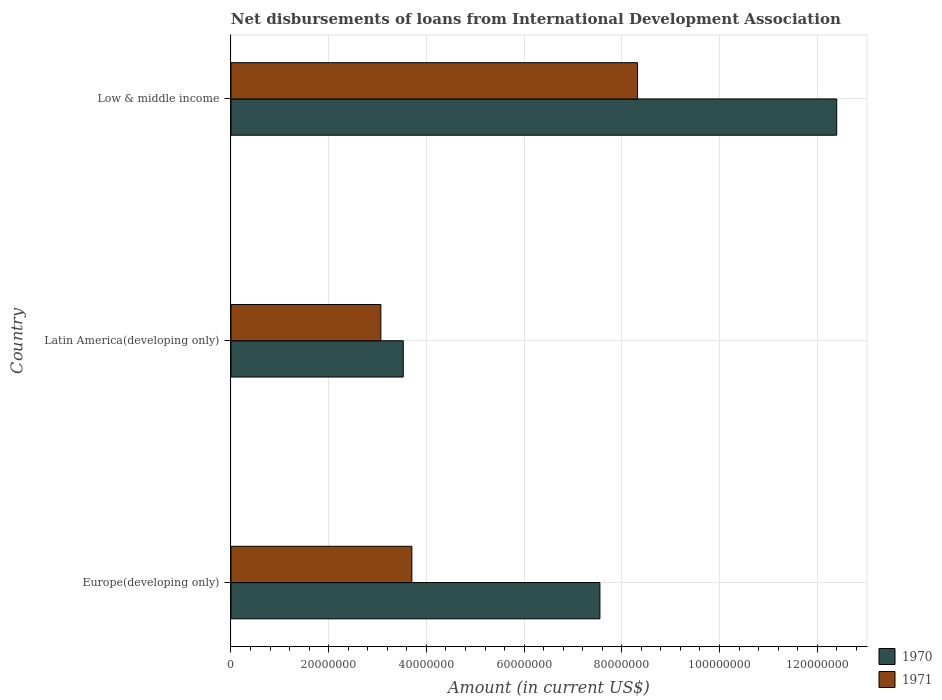How many different coloured bars are there?
Keep it short and to the point. 2. How many groups of bars are there?
Provide a succinct answer. 3. What is the amount of loans disbursed in 1971 in Low & middle income?
Make the answer very short. 8.32e+07. Across all countries, what is the maximum amount of loans disbursed in 1971?
Give a very brief answer. 8.32e+07. Across all countries, what is the minimum amount of loans disbursed in 1971?
Provide a succinct answer. 3.07e+07. In which country was the amount of loans disbursed in 1970 minimum?
Your answer should be very brief. Latin America(developing only). What is the total amount of loans disbursed in 1970 in the graph?
Your answer should be very brief. 2.35e+08. What is the difference between the amount of loans disbursed in 1971 in Europe(developing only) and that in Latin America(developing only)?
Provide a succinct answer. 6.35e+06. What is the difference between the amount of loans disbursed in 1970 in Europe(developing only) and the amount of loans disbursed in 1971 in Low & middle income?
Ensure brevity in your answer.  -7.70e+06. What is the average amount of loans disbursed in 1971 per country?
Give a very brief answer. 5.03e+07. What is the difference between the amount of loans disbursed in 1970 and amount of loans disbursed in 1971 in Low & middle income?
Make the answer very short. 4.08e+07. In how many countries, is the amount of loans disbursed in 1970 greater than 76000000 US$?
Ensure brevity in your answer.  1. What is the ratio of the amount of loans disbursed in 1971 in Europe(developing only) to that in Latin America(developing only)?
Ensure brevity in your answer.  1.21. Is the difference between the amount of loans disbursed in 1970 in Latin America(developing only) and Low & middle income greater than the difference between the amount of loans disbursed in 1971 in Latin America(developing only) and Low & middle income?
Provide a short and direct response. No. What is the difference between the highest and the second highest amount of loans disbursed in 1970?
Your response must be concise. 4.85e+07. What is the difference between the highest and the lowest amount of loans disbursed in 1970?
Keep it short and to the point. 8.87e+07. How many bars are there?
Your response must be concise. 6. Are all the bars in the graph horizontal?
Keep it short and to the point. Yes. How many countries are there in the graph?
Your answer should be compact. 3. Are the values on the major ticks of X-axis written in scientific E-notation?
Your response must be concise. No. Where does the legend appear in the graph?
Your answer should be compact. Bottom right. How many legend labels are there?
Your answer should be compact. 2. What is the title of the graph?
Keep it short and to the point. Net disbursements of loans from International Development Association. Does "1982" appear as one of the legend labels in the graph?
Make the answer very short. No. What is the label or title of the X-axis?
Make the answer very short. Amount (in current US$). What is the Amount (in current US$) in 1970 in Europe(developing only)?
Keep it short and to the point. 7.55e+07. What is the Amount (in current US$) of 1971 in Europe(developing only)?
Your answer should be very brief. 3.70e+07. What is the Amount (in current US$) in 1970 in Latin America(developing only)?
Give a very brief answer. 3.53e+07. What is the Amount (in current US$) of 1971 in Latin America(developing only)?
Make the answer very short. 3.07e+07. What is the Amount (in current US$) in 1970 in Low & middle income?
Your response must be concise. 1.24e+08. What is the Amount (in current US$) in 1971 in Low & middle income?
Provide a short and direct response. 8.32e+07. Across all countries, what is the maximum Amount (in current US$) in 1970?
Provide a succinct answer. 1.24e+08. Across all countries, what is the maximum Amount (in current US$) in 1971?
Provide a succinct answer. 8.32e+07. Across all countries, what is the minimum Amount (in current US$) of 1970?
Give a very brief answer. 3.53e+07. Across all countries, what is the minimum Amount (in current US$) in 1971?
Ensure brevity in your answer.  3.07e+07. What is the total Amount (in current US$) in 1970 in the graph?
Offer a very short reply. 2.35e+08. What is the total Amount (in current US$) of 1971 in the graph?
Your response must be concise. 1.51e+08. What is the difference between the Amount (in current US$) of 1970 in Europe(developing only) and that in Latin America(developing only)?
Keep it short and to the point. 4.03e+07. What is the difference between the Amount (in current US$) in 1971 in Europe(developing only) and that in Latin America(developing only)?
Give a very brief answer. 6.35e+06. What is the difference between the Amount (in current US$) of 1970 in Europe(developing only) and that in Low & middle income?
Provide a succinct answer. -4.85e+07. What is the difference between the Amount (in current US$) in 1971 in Europe(developing only) and that in Low & middle income?
Provide a succinct answer. -4.62e+07. What is the difference between the Amount (in current US$) of 1970 in Latin America(developing only) and that in Low & middle income?
Provide a short and direct response. -8.87e+07. What is the difference between the Amount (in current US$) in 1971 in Latin America(developing only) and that in Low & middle income?
Offer a terse response. -5.25e+07. What is the difference between the Amount (in current US$) in 1970 in Europe(developing only) and the Amount (in current US$) in 1971 in Latin America(developing only)?
Provide a succinct answer. 4.48e+07. What is the difference between the Amount (in current US$) of 1970 in Europe(developing only) and the Amount (in current US$) of 1971 in Low & middle income?
Your response must be concise. -7.70e+06. What is the difference between the Amount (in current US$) in 1970 in Latin America(developing only) and the Amount (in current US$) in 1971 in Low & middle income?
Offer a terse response. -4.80e+07. What is the average Amount (in current US$) of 1970 per country?
Ensure brevity in your answer.  7.83e+07. What is the average Amount (in current US$) in 1971 per country?
Provide a succinct answer. 5.03e+07. What is the difference between the Amount (in current US$) in 1970 and Amount (in current US$) in 1971 in Europe(developing only)?
Offer a terse response. 3.85e+07. What is the difference between the Amount (in current US$) in 1970 and Amount (in current US$) in 1971 in Latin America(developing only)?
Offer a terse response. 4.59e+06. What is the difference between the Amount (in current US$) in 1970 and Amount (in current US$) in 1971 in Low & middle income?
Offer a very short reply. 4.08e+07. What is the ratio of the Amount (in current US$) in 1970 in Europe(developing only) to that in Latin America(developing only)?
Your answer should be compact. 2.14. What is the ratio of the Amount (in current US$) in 1971 in Europe(developing only) to that in Latin America(developing only)?
Your answer should be compact. 1.21. What is the ratio of the Amount (in current US$) of 1970 in Europe(developing only) to that in Low & middle income?
Provide a short and direct response. 0.61. What is the ratio of the Amount (in current US$) of 1971 in Europe(developing only) to that in Low & middle income?
Provide a short and direct response. 0.44. What is the ratio of the Amount (in current US$) in 1970 in Latin America(developing only) to that in Low & middle income?
Ensure brevity in your answer.  0.28. What is the ratio of the Amount (in current US$) in 1971 in Latin America(developing only) to that in Low & middle income?
Offer a terse response. 0.37. What is the difference between the highest and the second highest Amount (in current US$) of 1970?
Make the answer very short. 4.85e+07. What is the difference between the highest and the second highest Amount (in current US$) of 1971?
Keep it short and to the point. 4.62e+07. What is the difference between the highest and the lowest Amount (in current US$) of 1970?
Make the answer very short. 8.87e+07. What is the difference between the highest and the lowest Amount (in current US$) of 1971?
Make the answer very short. 5.25e+07. 